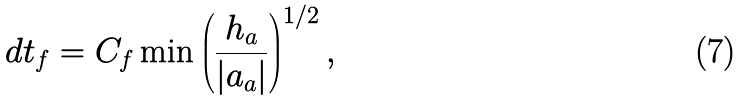<formula> <loc_0><loc_0><loc_500><loc_500>d t _ { f } = C _ { f } \min \left ( \frac { h _ { a } } { | a _ { a } | } \right ) ^ { 1 / 2 } ,</formula> 